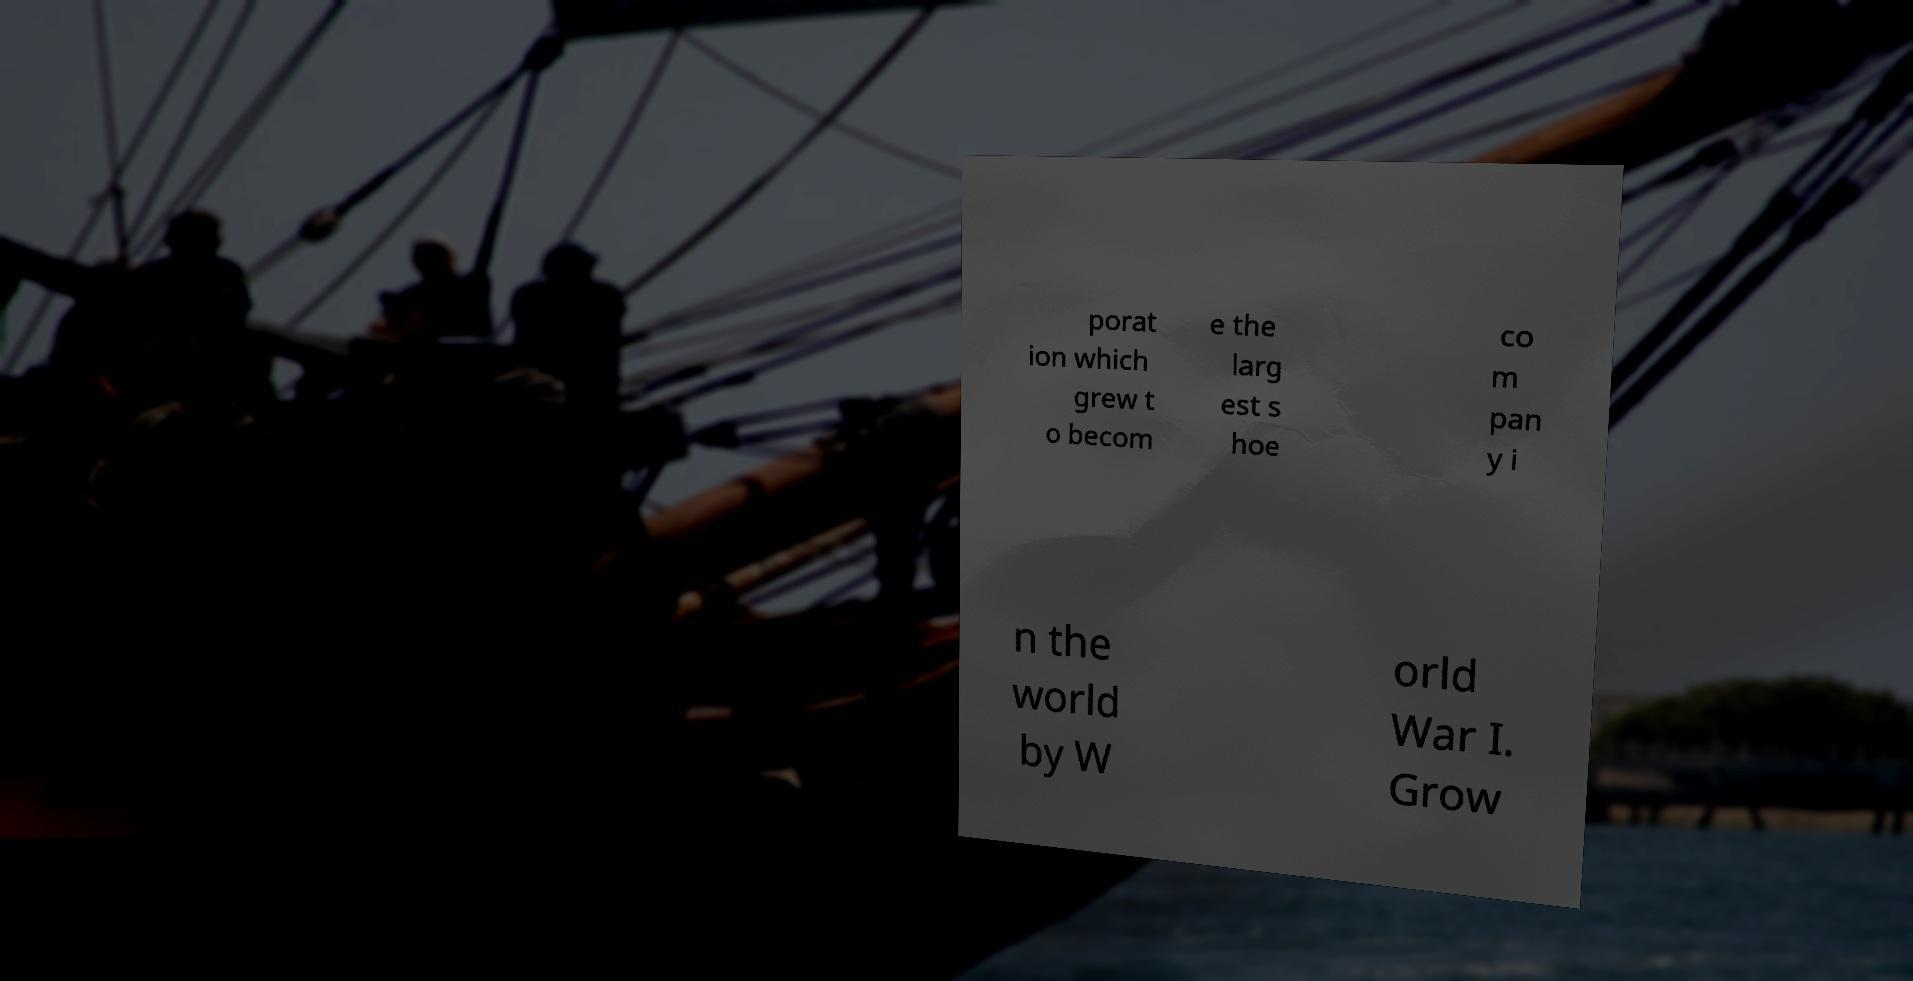Could you assist in decoding the text presented in this image and type it out clearly? porat ion which grew t o becom e the larg est s hoe co m pan y i n the world by W orld War I. Grow 